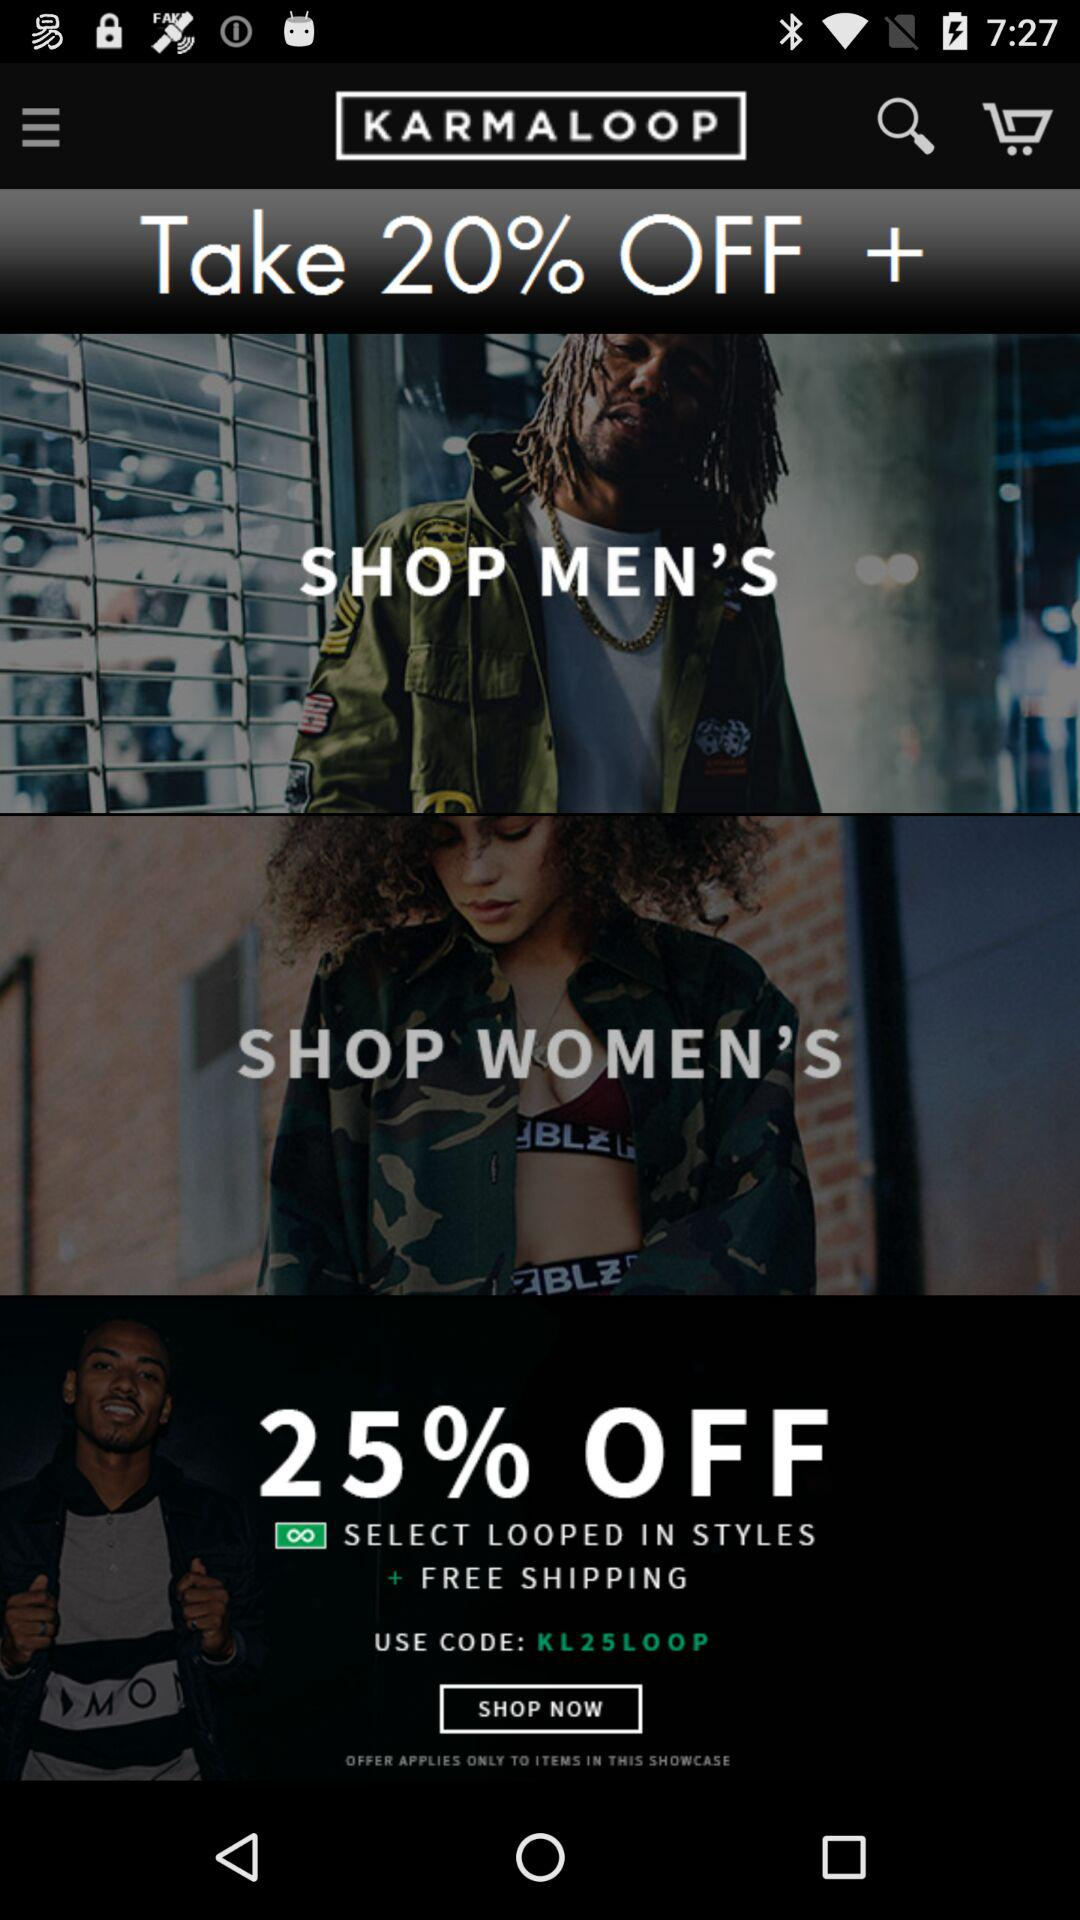How many percent off is the offer?
Answer the question using a single word or phrase. 25% 